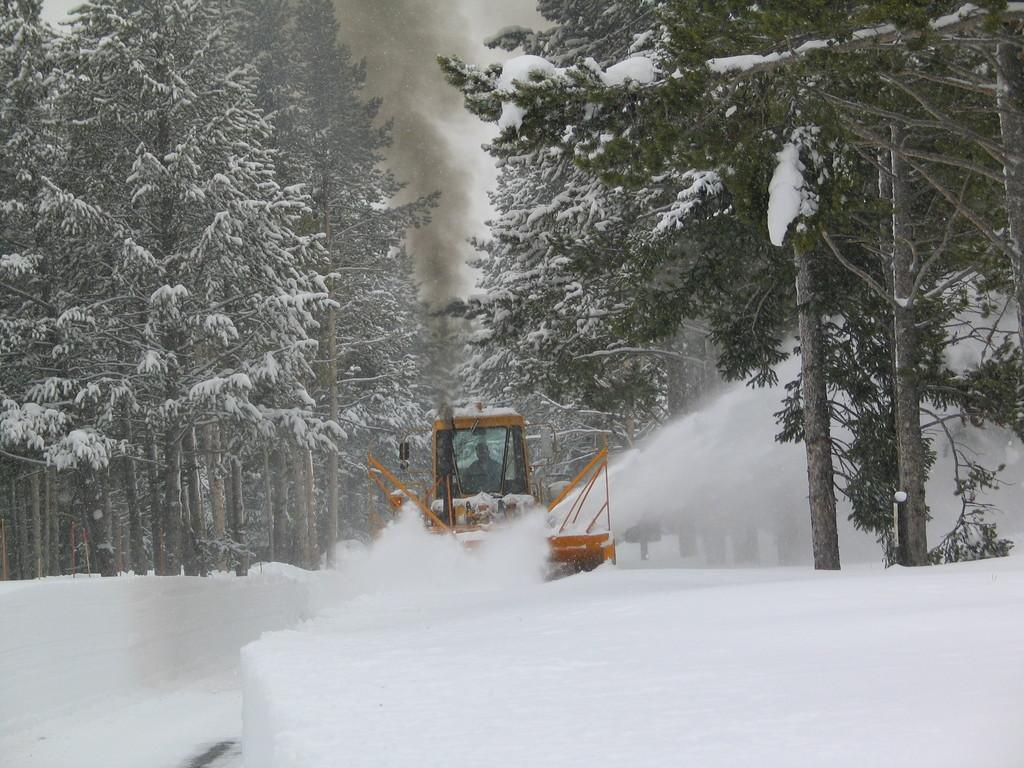What is the person in the image doing? There is a person driving a vehicle in the image. What type of road is the vehicle on? The vehicle is on an ice road. What can be seen in the background of the image? There are trees and smoke visible in the background. What might be the location of the image based on the surroundings? The image may have been taken near ice mountains. What type of ticket does the person in the image need to purchase for the ice road? There is no information about tickets or any need to purchase one in the image. --- Facts: 1. There is a person holding a book in the image. 2. The book has a blue cover. 3. The person is sitting on a chair. 4. There is a table next to the chair. 5. The table has a lamp on it. Absurd Topics: dance, ocean, bird Conversation: What is the person in the image holding? The person is holding a book in the image. What color is the book's cover? The book has a blue cover. What is the person sitting on? The person is sitting on a chair. What is located next to the chair? There is a table next to the chair. What object is on the table? The table has a lamp on it. Reasoning: Let's think step by step in order to produce the conversation. We start by identifying the main object the person is holding, which is a book. Then, we describe the book's cover color, which is blue. Next, we mention the person's seating arrangement, which is on a chair. We then describe the table next to the chair and the lamp on it. Each question is designed to elicit a specific detail about the image that is known from the provided facts. Absurd Question/Answer: Can you see any birds flying over the ocean in the image? There is no ocean or birds visible in the image; it features a person holding a book and sitting on a chair with a table and lamp nearby. 